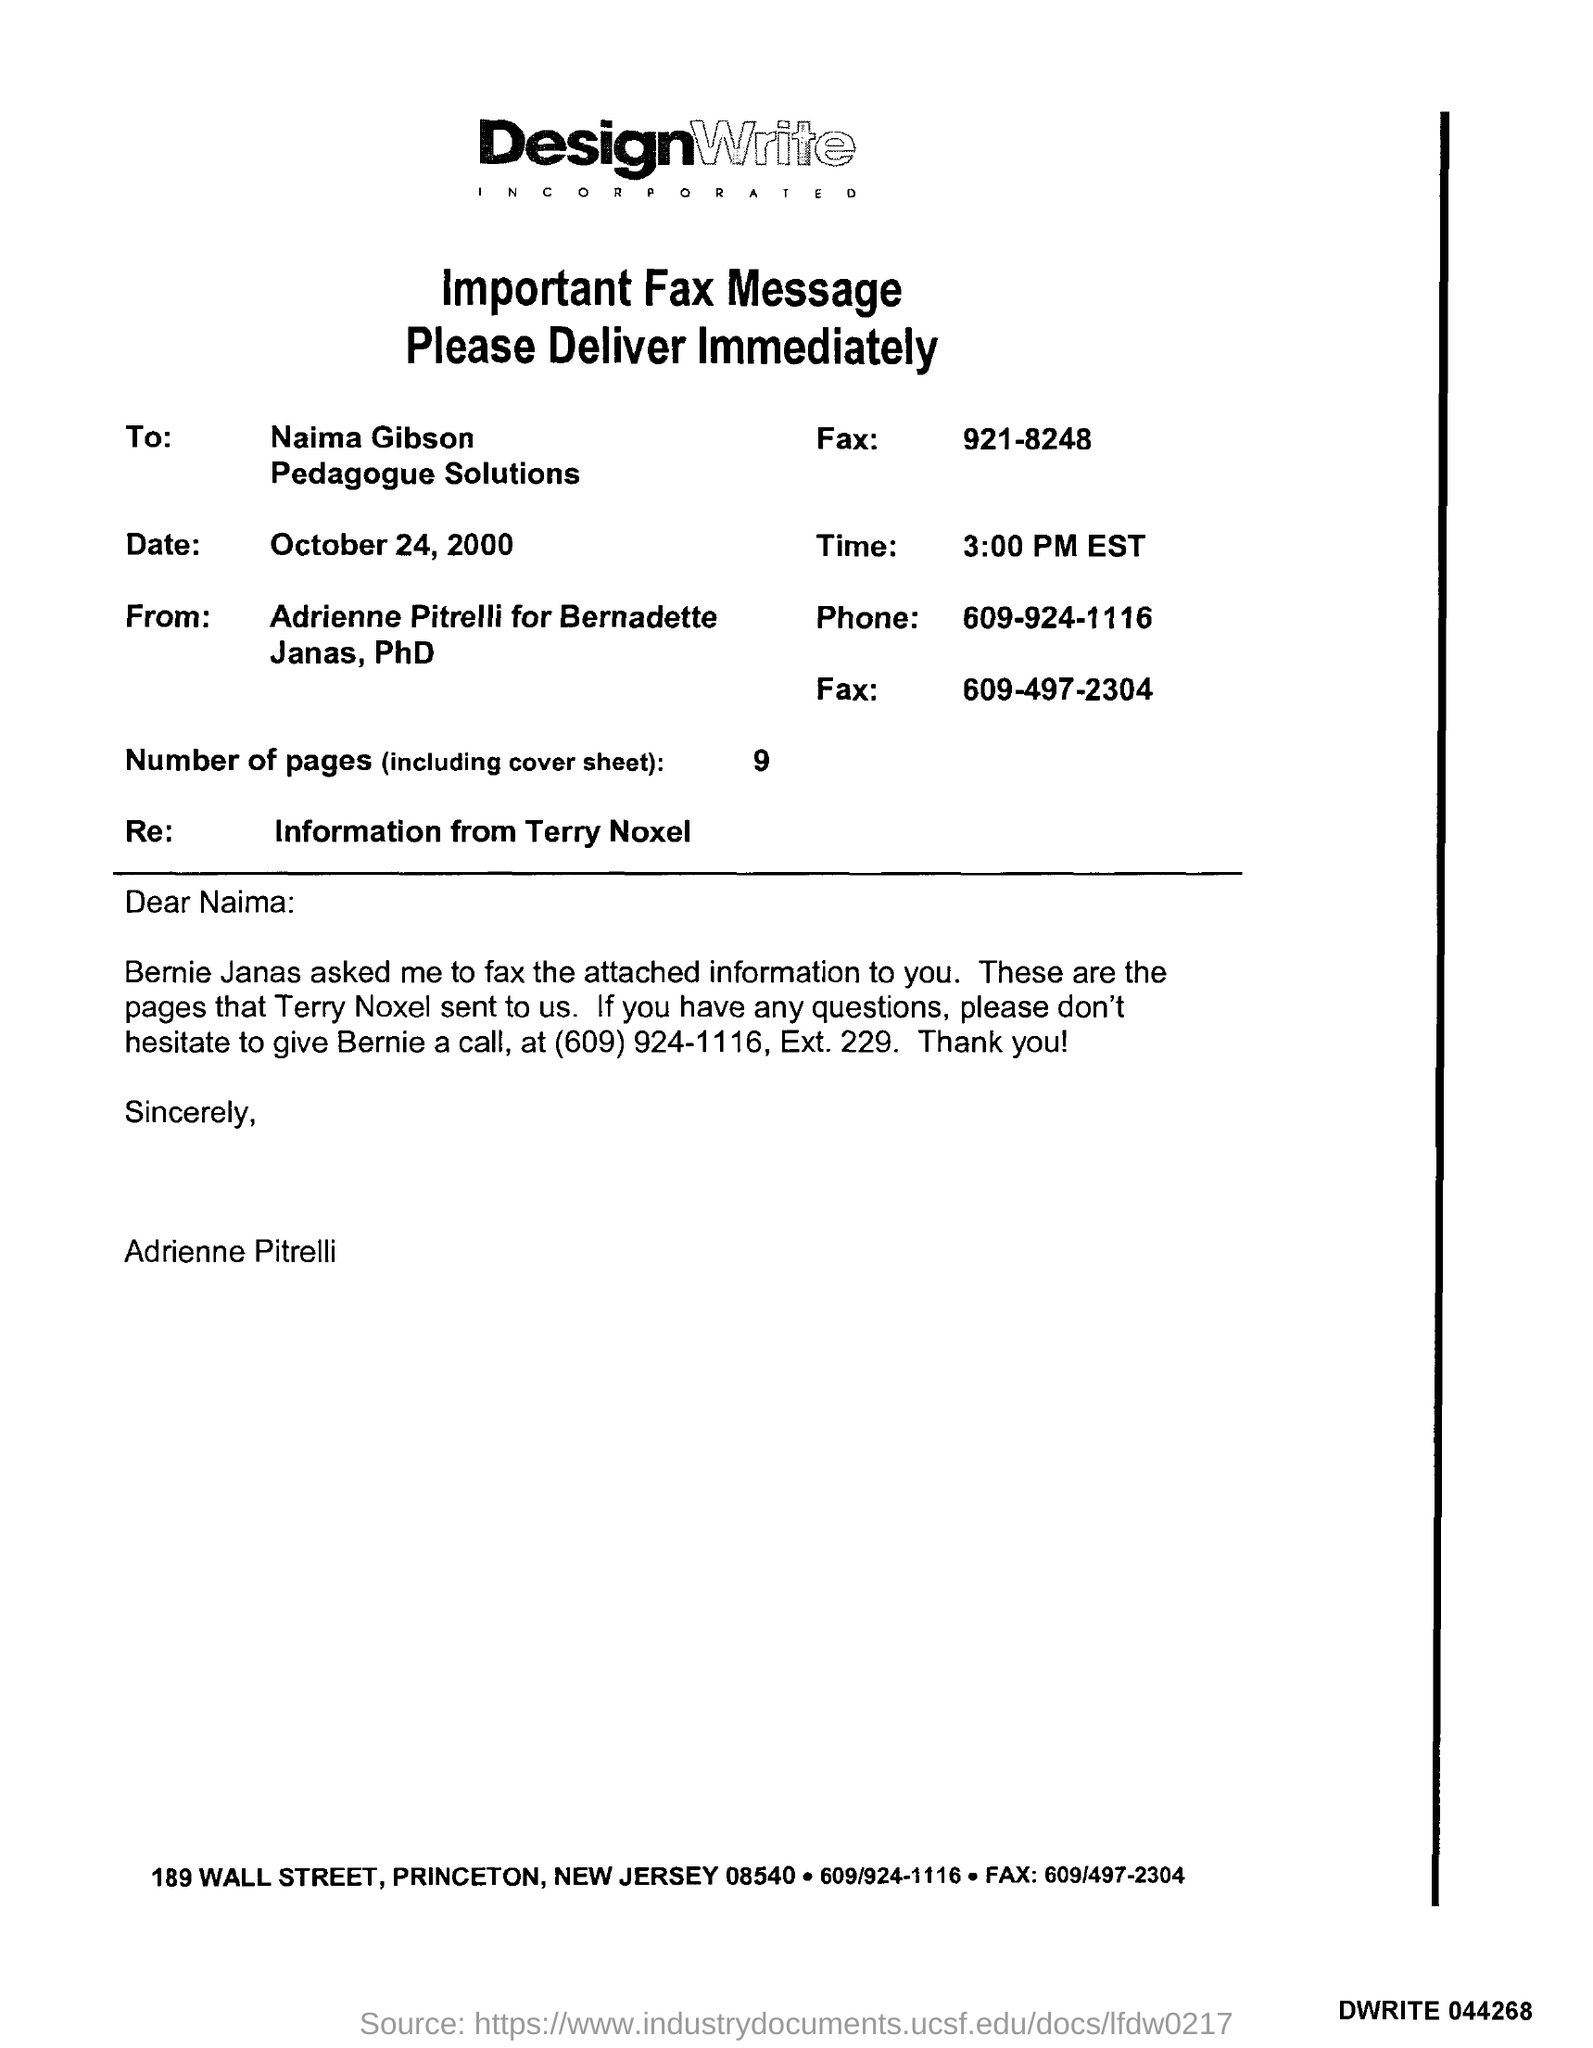Outline some significant characteristics in this image. The time mentioned in the fax is 3:00 PM EST. The date mentioned in the fax is October 24, 2000. There are 9 pages in the fax, including the cover sheet. The fax message is from DesignWrite. 